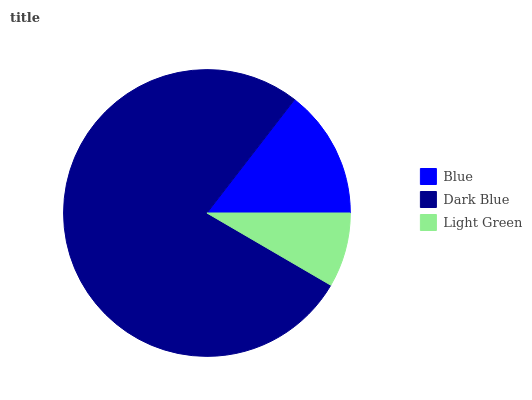Is Light Green the minimum?
Answer yes or no. Yes. Is Dark Blue the maximum?
Answer yes or no. Yes. Is Dark Blue the minimum?
Answer yes or no. No. Is Light Green the maximum?
Answer yes or no. No. Is Dark Blue greater than Light Green?
Answer yes or no. Yes. Is Light Green less than Dark Blue?
Answer yes or no. Yes. Is Light Green greater than Dark Blue?
Answer yes or no. No. Is Dark Blue less than Light Green?
Answer yes or no. No. Is Blue the high median?
Answer yes or no. Yes. Is Blue the low median?
Answer yes or no. Yes. Is Light Green the high median?
Answer yes or no. No. Is Dark Blue the low median?
Answer yes or no. No. 